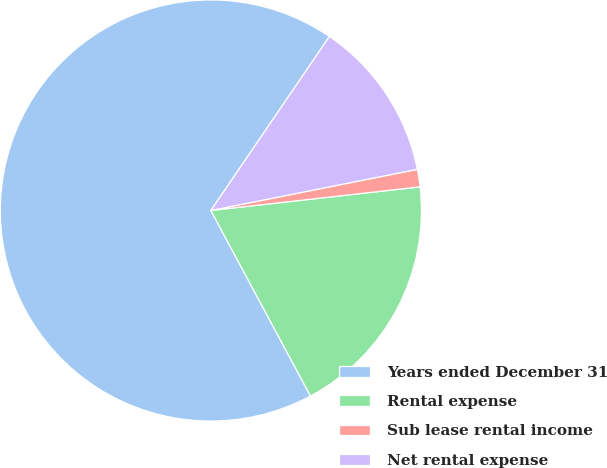Convert chart to OTSL. <chart><loc_0><loc_0><loc_500><loc_500><pie_chart><fcel>Years ended December 31<fcel>Rental expense<fcel>Sub lease rental income<fcel>Net rental expense<nl><fcel>67.36%<fcel>18.95%<fcel>1.34%<fcel>12.35%<nl></chart> 